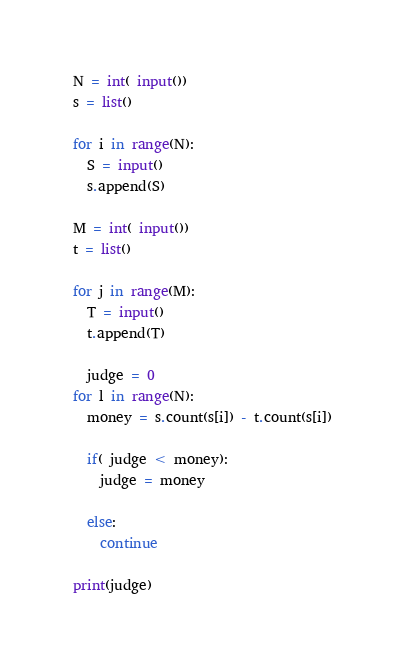<code> <loc_0><loc_0><loc_500><loc_500><_Python_>N = int( input())
s = list()

for i in range(N):
  S = input()
  s.append(S)
  
M = int( input())
t = list()

for j in range(M):
  T = input()
  t.append(T)

  judge = 0
for l in range(N):
  money = s.count(s[i]) - t.count(s[i])
  
  if( judge < money):
    judge = money
    
  else:
    continue
    
print(judge)</code> 